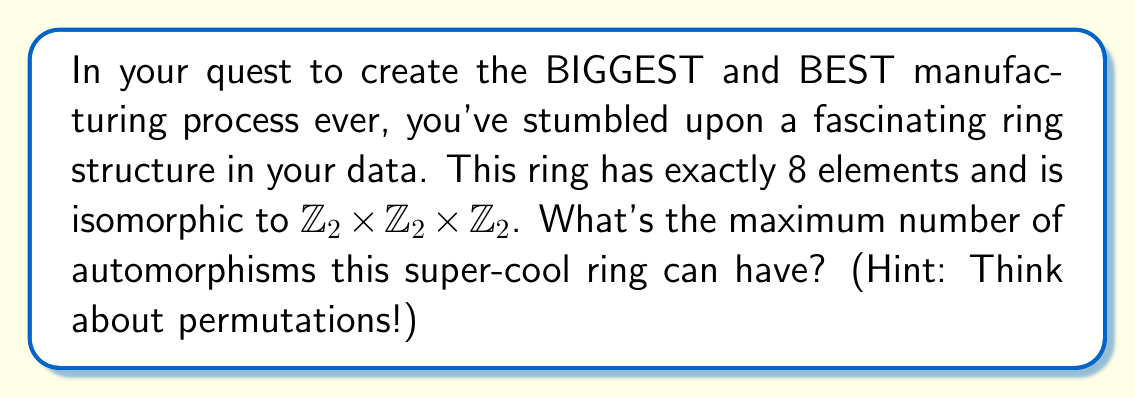Provide a solution to this math problem. Let's approach this step-by-step:

1) First, we need to understand what the ring $R = \mathbb{Z}_2 \times \mathbb{Z}_2 \times \mathbb{Z}_2$ looks like. It has 8 elements: $(0,0,0)$, $(0,0,1)$, $(0,1,0)$, $(1,0,0)$, $(0,1,1)$, $(1,0,1)$, $(1,1,0)$, $(1,1,1)$.

2) An automorphism of this ring is a bijective function $f: R \rightarrow R$ that preserves both addition and multiplication.

3) The key observation is that any automorphism must map the identity element $(0,0,0)$ to itself, and must map the other non-zero elements to non-zero elements.

4) Moreover, each non-zero element is its own additive inverse (as we're working in $\mathbb{Z}_2$), so the automorphisms are actually just permutations of the non-zero elements.

5) There are 7 non-zero elements, so the maximum number of automorphisms is equal to the number of permutations of 7 elements.

6) The number of permutations of $n$ elements is given by $n!$.

7) Therefore, the maximum number of automorphisms is $7! = 7 \times 6 \times 5 \times 4 \times 3 \times 2 \times 1 = 5040$.

This is indeed the actual number of automorphisms for this ring, as every permutation of the non-zero elements does give a valid automorphism.
Answer: The maximal size of the automorphism group for the ring $\mathbb{Z}_2 \times \mathbb{Z}_2 \times \mathbb{Z}_2$ is $7! = 5040$. 